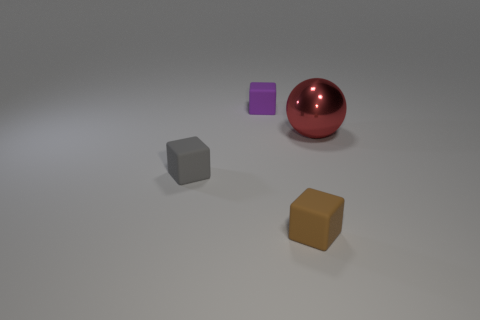What number of gray matte things have the same size as the purple cube?
Your answer should be very brief. 1. What is the material of the tiny brown thing that is the same shape as the gray rubber thing?
Offer a very short reply. Rubber. The rubber thing that is behind the small brown rubber object and in front of the small purple rubber cube has what shape?
Ensure brevity in your answer.  Cube. What is the shape of the matte thing behind the gray block?
Your answer should be compact. Cube. What number of small rubber cubes are both behind the small brown cube and in front of the purple rubber thing?
Your response must be concise. 1. There is a red sphere; does it have the same size as the cube that is behind the red metallic sphere?
Offer a very short reply. No. There is a thing that is behind the thing right of the tiny cube in front of the tiny gray matte block; what size is it?
Your answer should be very brief. Small. How big is the brown object left of the big red shiny ball?
Your answer should be compact. Small. There is a tiny purple thing that is the same material as the brown object; what shape is it?
Your answer should be compact. Cube. Is the material of the small cube behind the gray matte cube the same as the red thing?
Make the answer very short. No. 